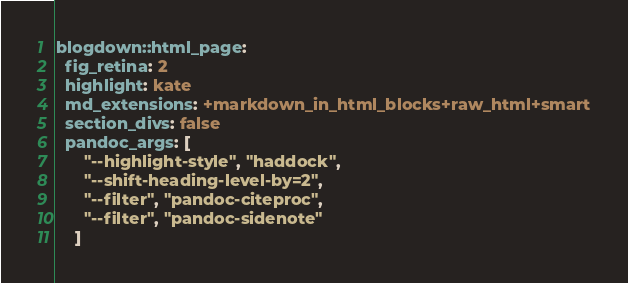<code> <loc_0><loc_0><loc_500><loc_500><_YAML_>blogdown::html_page:
  fig_retina: 2
  highlight: kate
  md_extensions: +markdown_in_html_blocks+raw_html+smart
  section_divs: false
  pandoc_args: [
      "--highlight-style", "haddock",
      "--shift-heading-level-by=2",
      "--filter", "pandoc-citeproc",
      "--filter", "pandoc-sidenote" 
    ]
</code> 